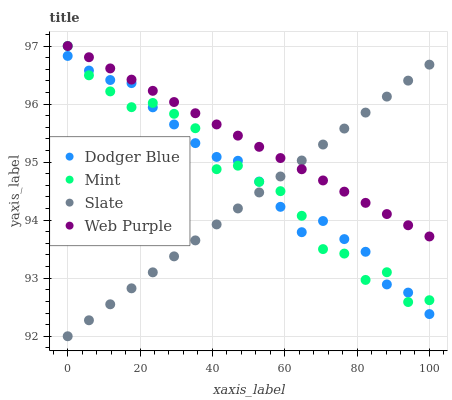Does Slate have the minimum area under the curve?
Answer yes or no. Yes. Does Web Purple have the maximum area under the curve?
Answer yes or no. Yes. Does Dodger Blue have the minimum area under the curve?
Answer yes or no. No. Does Dodger Blue have the maximum area under the curve?
Answer yes or no. No. Is Slate the smoothest?
Answer yes or no. Yes. Is Mint the roughest?
Answer yes or no. Yes. Is Dodger Blue the smoothest?
Answer yes or no. No. Is Dodger Blue the roughest?
Answer yes or no. No. Does Slate have the lowest value?
Answer yes or no. Yes. Does Dodger Blue have the lowest value?
Answer yes or no. No. Does Web Purple have the highest value?
Answer yes or no. Yes. Does Dodger Blue have the highest value?
Answer yes or no. No. Is Dodger Blue less than Web Purple?
Answer yes or no. Yes. Is Web Purple greater than Dodger Blue?
Answer yes or no. Yes. Does Web Purple intersect Mint?
Answer yes or no. Yes. Is Web Purple less than Mint?
Answer yes or no. No. Is Web Purple greater than Mint?
Answer yes or no. No. Does Dodger Blue intersect Web Purple?
Answer yes or no. No. 